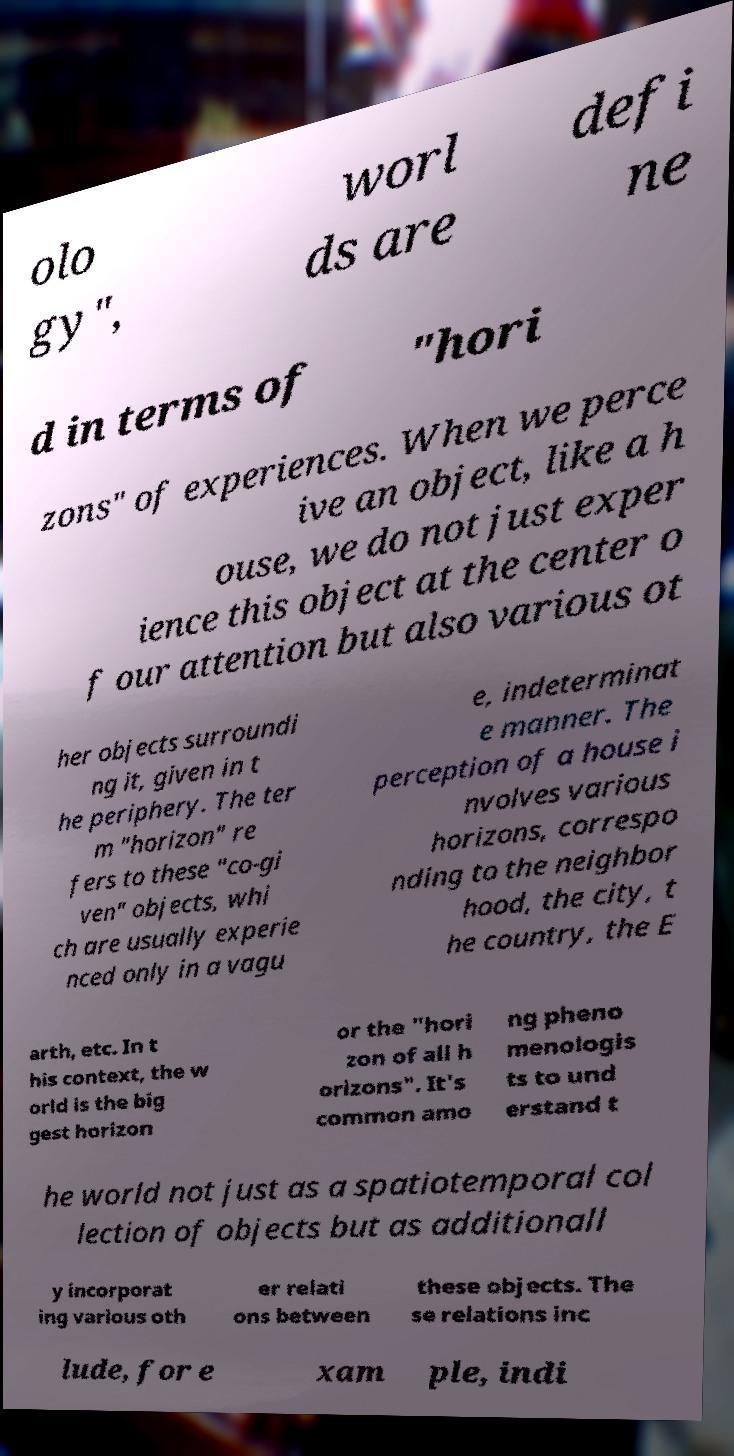Could you extract and type out the text from this image? olo gy", worl ds are defi ne d in terms of "hori zons" of experiences. When we perce ive an object, like a h ouse, we do not just exper ience this object at the center o f our attention but also various ot her objects surroundi ng it, given in t he periphery. The ter m "horizon" re fers to these "co-gi ven" objects, whi ch are usually experie nced only in a vagu e, indeterminat e manner. The perception of a house i nvolves various horizons, correspo nding to the neighbor hood, the city, t he country, the E arth, etc. In t his context, the w orld is the big gest horizon or the "hori zon of all h orizons". It's common amo ng pheno menologis ts to und erstand t he world not just as a spatiotemporal col lection of objects but as additionall y incorporat ing various oth er relati ons between these objects. The se relations inc lude, for e xam ple, indi 